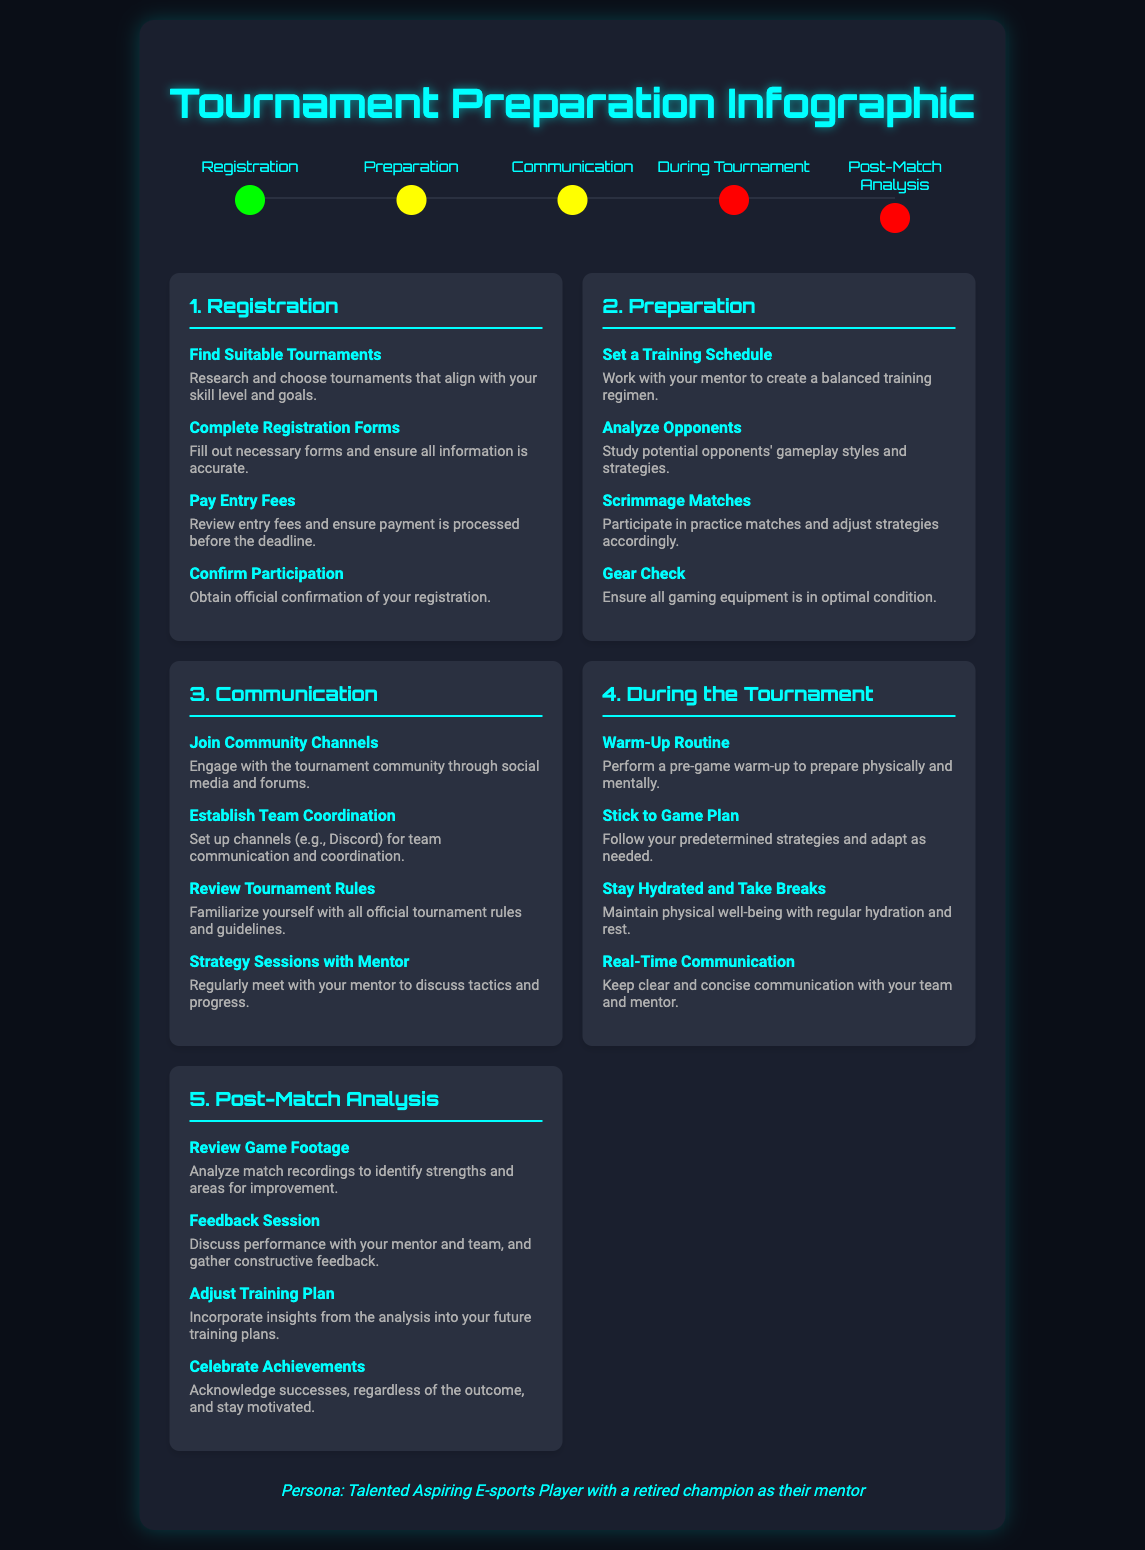What is the first stage in the timeline? The timeline starts with the "Registration" stage.
Answer: Registration How many tasks are listed under "Preparation"? There are four tasks outlined in the "Preparation" section.
Answer: 4 What is one way to prepare for the tournament mentioned under "Preparation"? "Analyze Opponents" is listed as a preparation task to understand potential adversaries.
Answer: Analyze Opponents What color indicates the "In Progress" stages? The "In Progress" stages are represented by a yellow color.
Answer: Yellow What should be reviewed according to the "Communication" section? The "Review Tournament Rules" task emphasizes the need to understand the official tournament guidelines.
Answer: Tournament Rules What task is recommended during the tournament related to communication? "Real-Time Communication" is emphasized for maintaining clarity with the team.
Answer: Real-Time Communication What is a recommended activity listed in "Post-Match Analysis"? "Review Game Footage" is a key activity for analyzing match performance.
Answer: Review Game Footage What color represents the "Complete" stage in the timeline? The "Complete" stage is marked by a green color.
Answer: Green What should be done after discussing performance in "Post-Match Analysis"? The task of "Adjust Training Plan" follows the feedback session.
Answer: Adjust Training Plan 